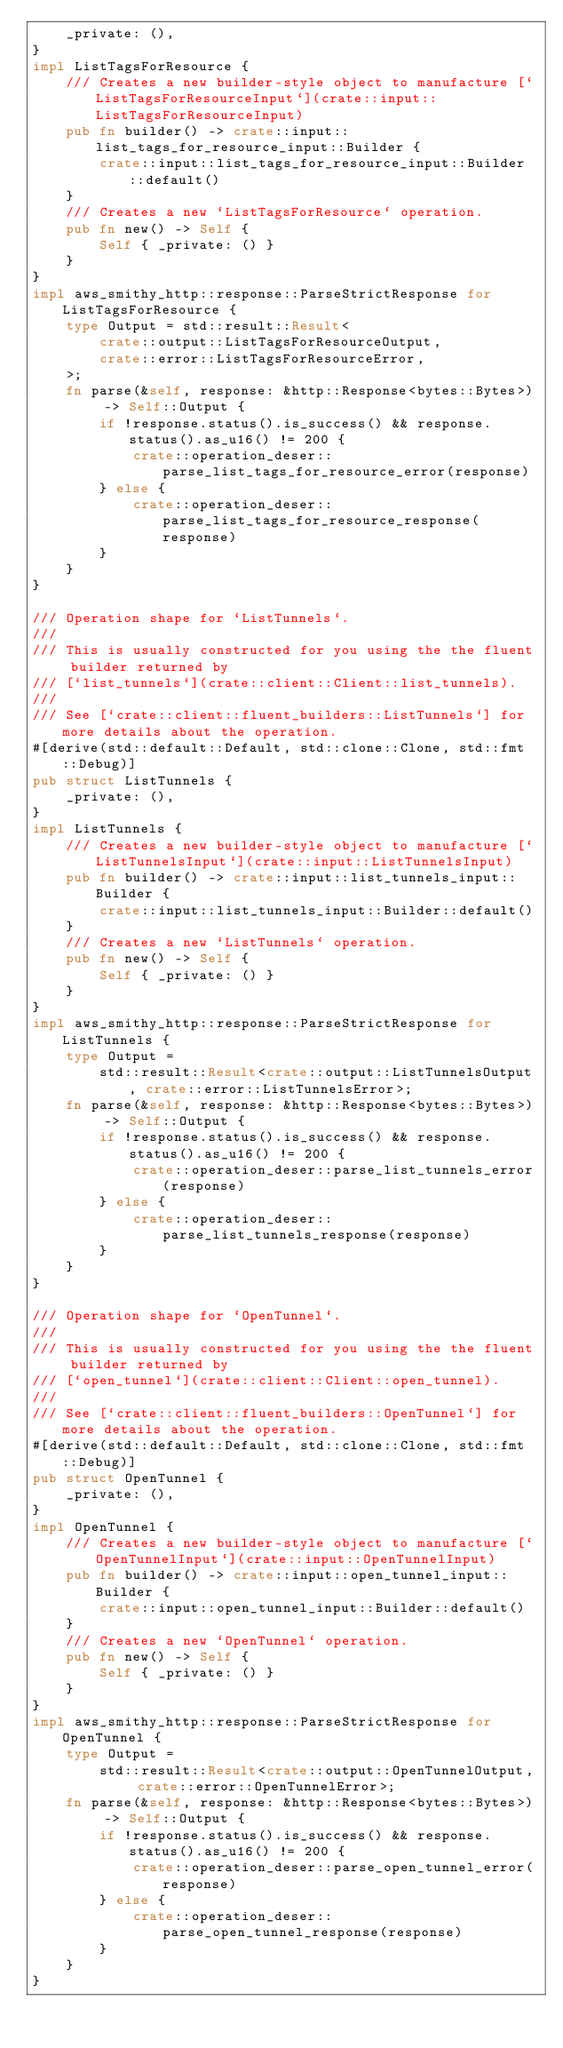<code> <loc_0><loc_0><loc_500><loc_500><_Rust_>    _private: (),
}
impl ListTagsForResource {
    /// Creates a new builder-style object to manufacture [`ListTagsForResourceInput`](crate::input::ListTagsForResourceInput)
    pub fn builder() -> crate::input::list_tags_for_resource_input::Builder {
        crate::input::list_tags_for_resource_input::Builder::default()
    }
    /// Creates a new `ListTagsForResource` operation.
    pub fn new() -> Self {
        Self { _private: () }
    }
}
impl aws_smithy_http::response::ParseStrictResponse for ListTagsForResource {
    type Output = std::result::Result<
        crate::output::ListTagsForResourceOutput,
        crate::error::ListTagsForResourceError,
    >;
    fn parse(&self, response: &http::Response<bytes::Bytes>) -> Self::Output {
        if !response.status().is_success() && response.status().as_u16() != 200 {
            crate::operation_deser::parse_list_tags_for_resource_error(response)
        } else {
            crate::operation_deser::parse_list_tags_for_resource_response(response)
        }
    }
}

/// Operation shape for `ListTunnels`.
///
/// This is usually constructed for you using the the fluent builder returned by
/// [`list_tunnels`](crate::client::Client::list_tunnels).
///
/// See [`crate::client::fluent_builders::ListTunnels`] for more details about the operation.
#[derive(std::default::Default, std::clone::Clone, std::fmt::Debug)]
pub struct ListTunnels {
    _private: (),
}
impl ListTunnels {
    /// Creates a new builder-style object to manufacture [`ListTunnelsInput`](crate::input::ListTunnelsInput)
    pub fn builder() -> crate::input::list_tunnels_input::Builder {
        crate::input::list_tunnels_input::Builder::default()
    }
    /// Creates a new `ListTunnels` operation.
    pub fn new() -> Self {
        Self { _private: () }
    }
}
impl aws_smithy_http::response::ParseStrictResponse for ListTunnels {
    type Output =
        std::result::Result<crate::output::ListTunnelsOutput, crate::error::ListTunnelsError>;
    fn parse(&self, response: &http::Response<bytes::Bytes>) -> Self::Output {
        if !response.status().is_success() && response.status().as_u16() != 200 {
            crate::operation_deser::parse_list_tunnels_error(response)
        } else {
            crate::operation_deser::parse_list_tunnels_response(response)
        }
    }
}

/// Operation shape for `OpenTunnel`.
///
/// This is usually constructed for you using the the fluent builder returned by
/// [`open_tunnel`](crate::client::Client::open_tunnel).
///
/// See [`crate::client::fluent_builders::OpenTunnel`] for more details about the operation.
#[derive(std::default::Default, std::clone::Clone, std::fmt::Debug)]
pub struct OpenTunnel {
    _private: (),
}
impl OpenTunnel {
    /// Creates a new builder-style object to manufacture [`OpenTunnelInput`](crate::input::OpenTunnelInput)
    pub fn builder() -> crate::input::open_tunnel_input::Builder {
        crate::input::open_tunnel_input::Builder::default()
    }
    /// Creates a new `OpenTunnel` operation.
    pub fn new() -> Self {
        Self { _private: () }
    }
}
impl aws_smithy_http::response::ParseStrictResponse for OpenTunnel {
    type Output =
        std::result::Result<crate::output::OpenTunnelOutput, crate::error::OpenTunnelError>;
    fn parse(&self, response: &http::Response<bytes::Bytes>) -> Self::Output {
        if !response.status().is_success() && response.status().as_u16() != 200 {
            crate::operation_deser::parse_open_tunnel_error(response)
        } else {
            crate::operation_deser::parse_open_tunnel_response(response)
        }
    }
}
</code> 